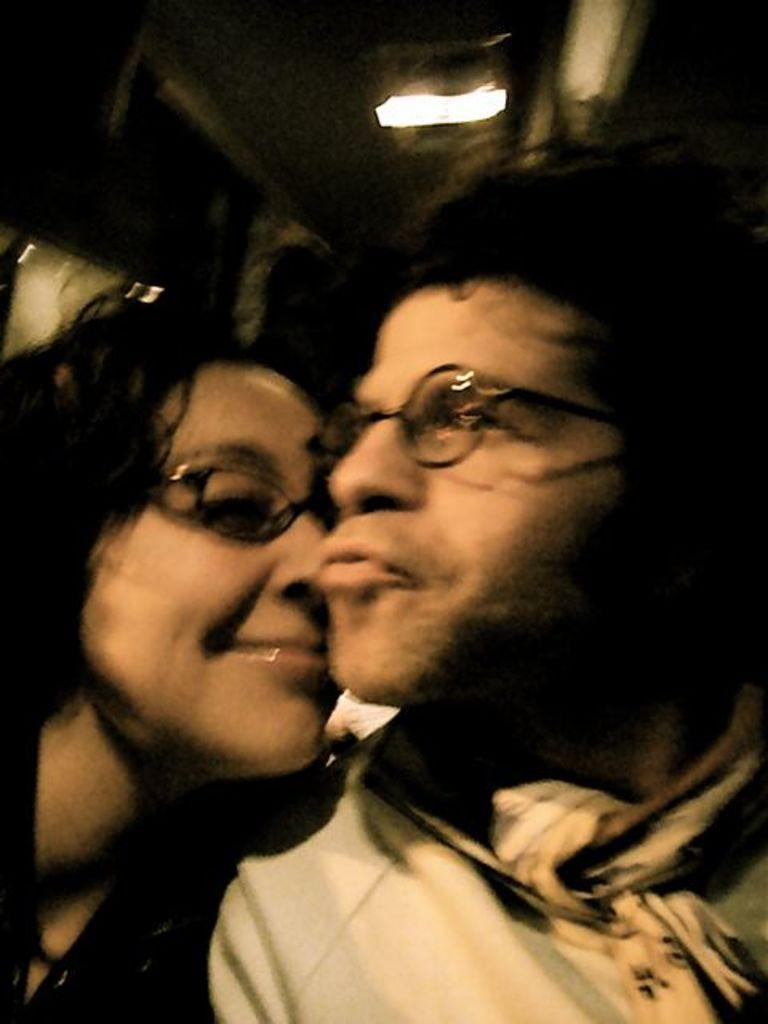How would you summarize this image in a sentence or two? In this picture I can observe a couple. Both of them are wearing spectacles. The picture is partially blurred. In the background I can observe a light. 